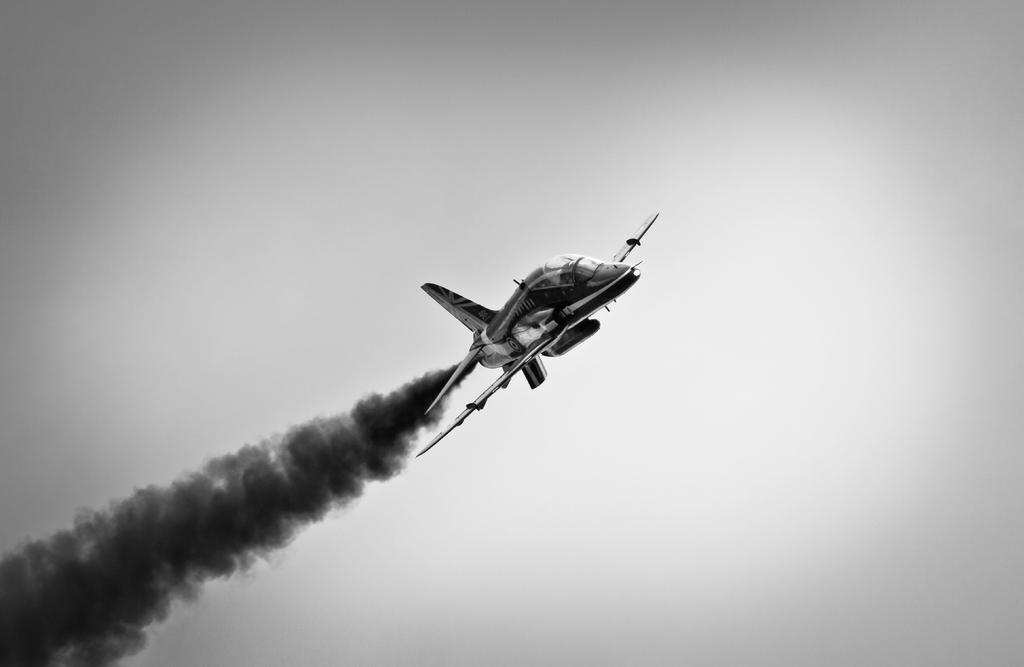What is the color scheme of the image? The image is black and white. What is the main subject of the image? There is an airplane flying in the air in the middle of the image. What can be seen on the left side of the image? Fumes are visible on the left side of the image. What is the color of the background in the image? The background of the image is white. How many trains are visible in the image? There are no trains present in the image. What type of lumber is being transported by the airplane in the image? There is no lumber visible in the image, and the airplane is not transporting any cargo. 